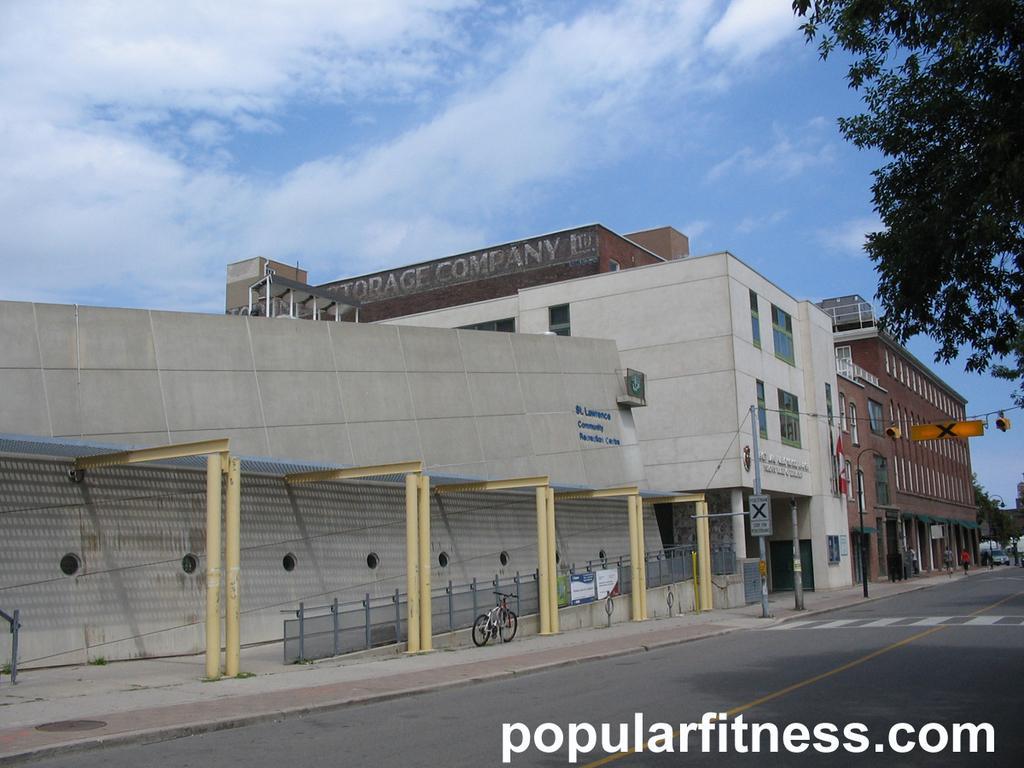Please provide a concise description of this image. These are buildings, this is bicycle and a tree, this is road and a sky. 